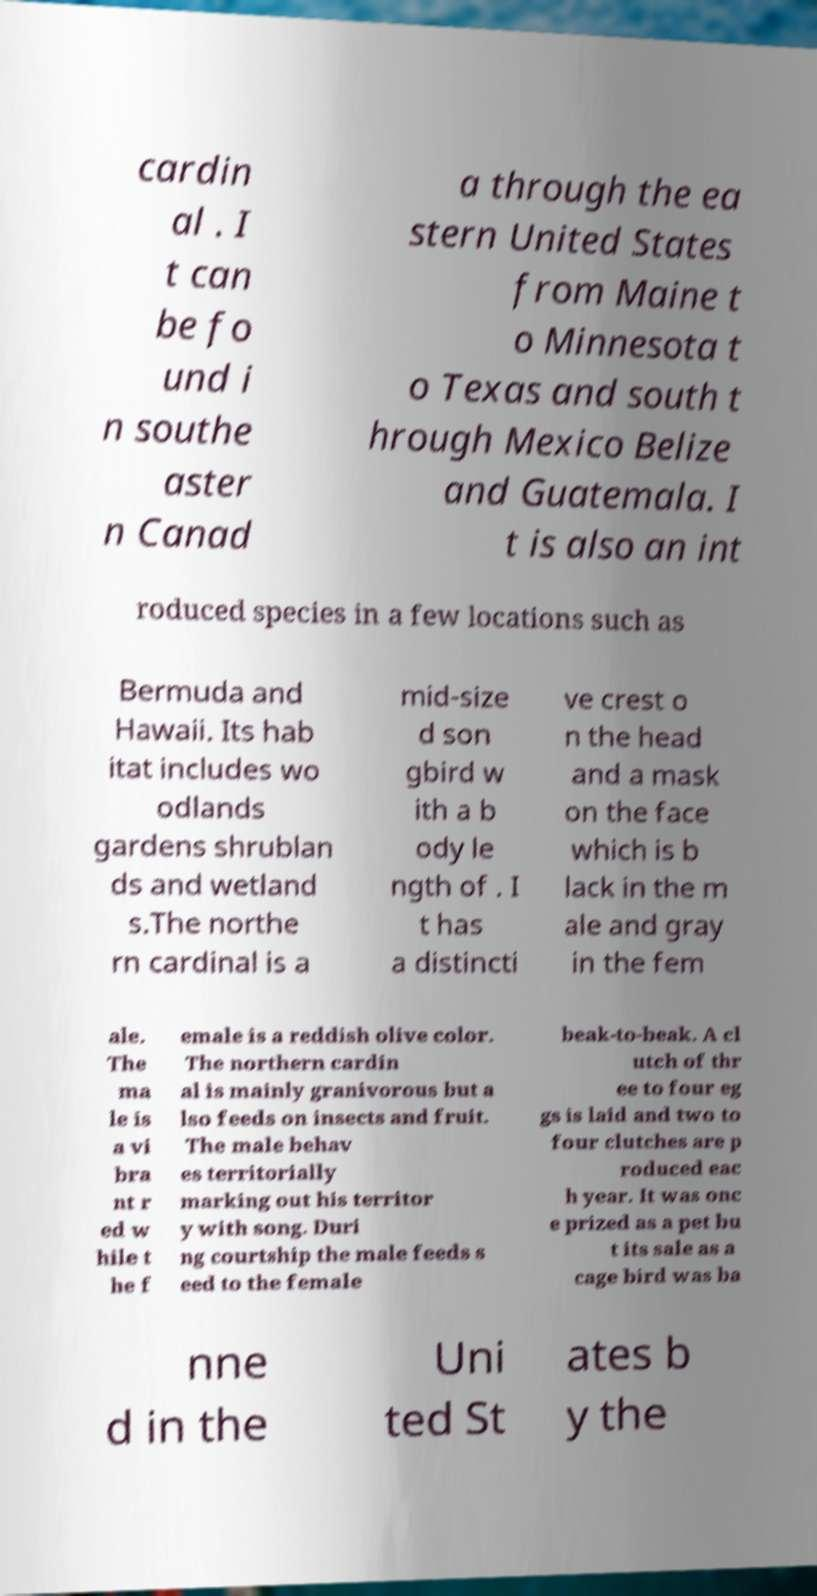Please identify and transcribe the text found in this image. cardin al . I t can be fo und i n southe aster n Canad a through the ea stern United States from Maine t o Minnesota t o Texas and south t hrough Mexico Belize and Guatemala. I t is also an int roduced species in a few locations such as Bermuda and Hawaii. Its hab itat includes wo odlands gardens shrublan ds and wetland s.The northe rn cardinal is a mid-size d son gbird w ith a b ody le ngth of . I t has a distincti ve crest o n the head and a mask on the face which is b lack in the m ale and gray in the fem ale. The ma le is a vi bra nt r ed w hile t he f emale is a reddish olive color. The northern cardin al is mainly granivorous but a lso feeds on insects and fruit. The male behav es territorially marking out his territor y with song. Duri ng courtship the male feeds s eed to the female beak-to-beak. A cl utch of thr ee to four eg gs is laid and two to four clutches are p roduced eac h year. It was onc e prized as a pet bu t its sale as a cage bird was ba nne d in the Uni ted St ates b y the 